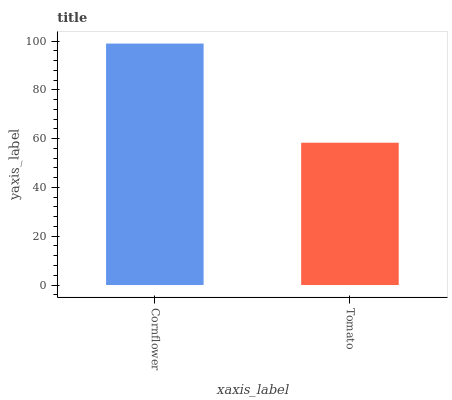Is Tomato the minimum?
Answer yes or no. Yes. Is Cornflower the maximum?
Answer yes or no. Yes. Is Tomato the maximum?
Answer yes or no. No. Is Cornflower greater than Tomato?
Answer yes or no. Yes. Is Tomato less than Cornflower?
Answer yes or no. Yes. Is Tomato greater than Cornflower?
Answer yes or no. No. Is Cornflower less than Tomato?
Answer yes or no. No. Is Cornflower the high median?
Answer yes or no. Yes. Is Tomato the low median?
Answer yes or no. Yes. Is Tomato the high median?
Answer yes or no. No. Is Cornflower the low median?
Answer yes or no. No. 